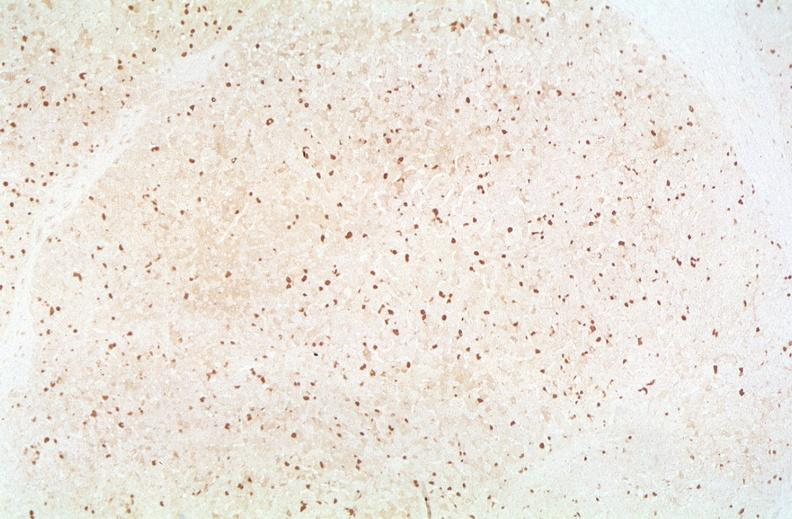does this image show hepatitis b virus, hbv surface antigen immunohistochemistry?
Answer the question using a single word or phrase. Yes 